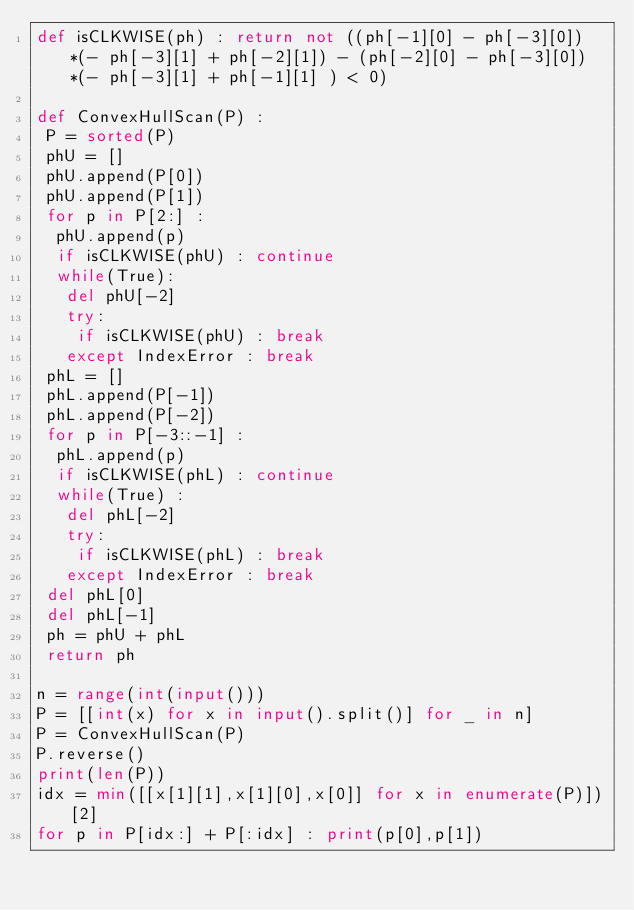Convert code to text. <code><loc_0><loc_0><loc_500><loc_500><_Python_>def isCLKWISE(ph) : return not ((ph[-1][0] - ph[-3][0])*(- ph[-3][1] + ph[-2][1]) - (ph[-2][0] - ph[-3][0])*(- ph[-3][1] + ph[-1][1] ) < 0)
      
def ConvexHullScan(P) :
 P = sorted(P)
 phU = []
 phU.append(P[0])
 phU.append(P[1])
 for p in P[2:] :
  phU.append(p)
  if isCLKWISE(phU) : continue
  while(True):
   del phU[-2]
   try:
    if isCLKWISE(phU) : break
   except IndexError : break
 phL = []
 phL.append(P[-1])
 phL.append(P[-2])
 for p in P[-3::-1] :
  phL.append(p)
  if isCLKWISE(phL) : continue
  while(True) :
   del phL[-2]
   try:
    if isCLKWISE(phL) : break
   except IndexError : break
 del phL[0]
 del phL[-1]
 ph = phU + phL
 return ph
  
n = range(int(input()))
P = [[int(x) for x in input().split()] for _ in n]
P = ConvexHullScan(P)
P.reverse()
print(len(P))
idx = min([[x[1][1],x[1][0],x[0]] for x in enumerate(P)])[2]
for p in P[idx:] + P[:idx] : print(p[0],p[1])</code> 